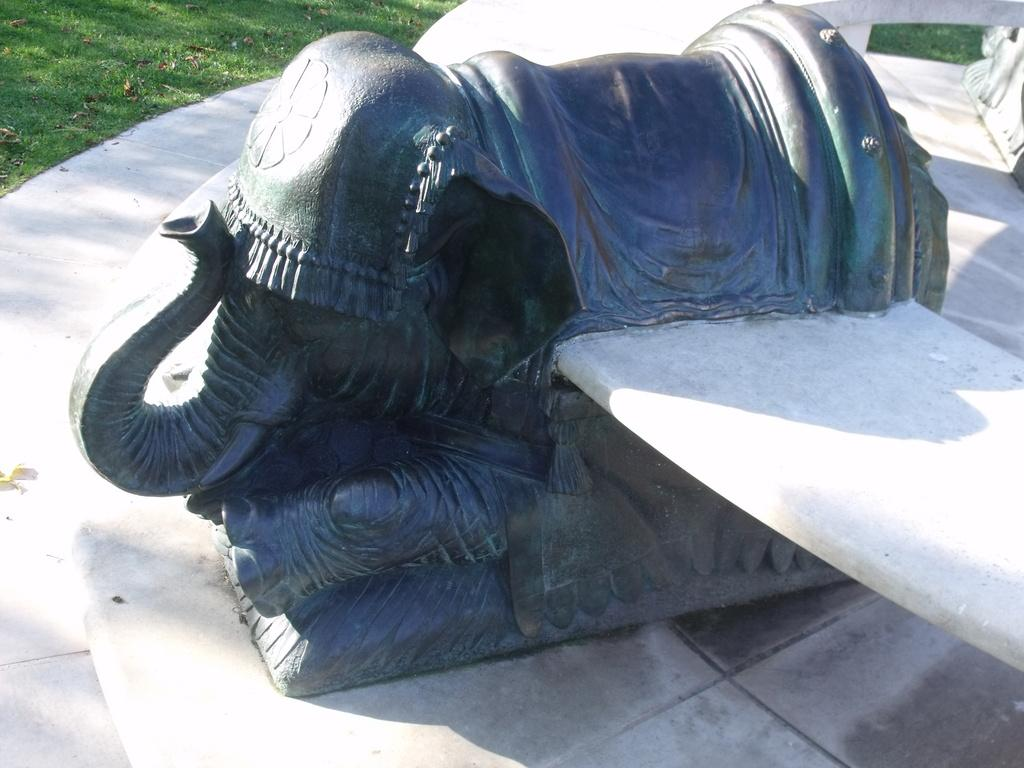What is the main subject of the image? There is a statue of an elephant in the middle of the image. What type of vegetation can be seen in the image? There is grass visible in the image. What type of yoke is being used by the elephant in the image? There is no yoke present in the image, as it features a statue of an elephant and not a real elephant. 